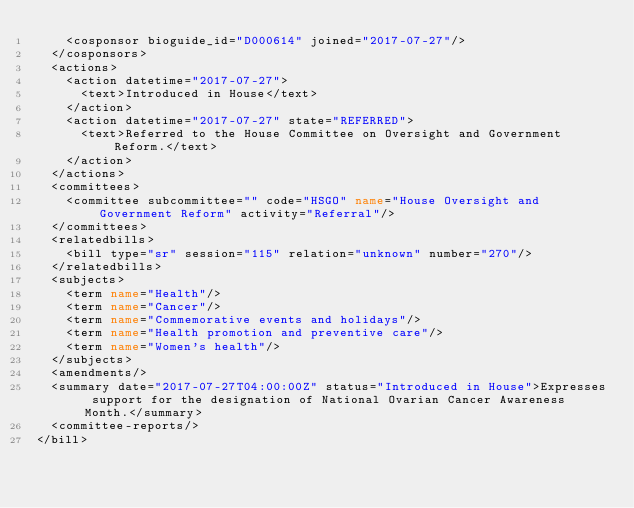Convert code to text. <code><loc_0><loc_0><loc_500><loc_500><_XML_>    <cosponsor bioguide_id="D000614" joined="2017-07-27"/>
  </cosponsors>
  <actions>
    <action datetime="2017-07-27">
      <text>Introduced in House</text>
    </action>
    <action datetime="2017-07-27" state="REFERRED">
      <text>Referred to the House Committee on Oversight and Government Reform.</text>
    </action>
  </actions>
  <committees>
    <committee subcommittee="" code="HSGO" name="House Oversight and Government Reform" activity="Referral"/>
  </committees>
  <relatedbills>
    <bill type="sr" session="115" relation="unknown" number="270"/>
  </relatedbills>
  <subjects>
    <term name="Health"/>
    <term name="Cancer"/>
    <term name="Commemorative events and holidays"/>
    <term name="Health promotion and preventive care"/>
    <term name="Women's health"/>
  </subjects>
  <amendments/>
  <summary date="2017-07-27T04:00:00Z" status="Introduced in House">Expresses support for the designation of National Ovarian Cancer Awareness Month.</summary>
  <committee-reports/>
</bill>
</code> 